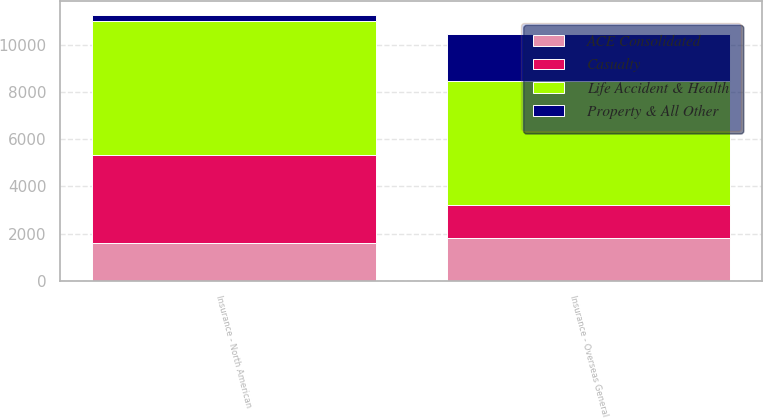Convert chart. <chart><loc_0><loc_0><loc_500><loc_500><stacked_bar_chart><ecel><fcel>Insurance - North American<fcel>Insurance - Overseas General<nl><fcel>ACE Consolidated<fcel>1578<fcel>1800<nl><fcel>Casualty<fcel>3777<fcel>1424<nl><fcel>Property & All Other<fcel>296<fcel>2016<nl><fcel>Life Accident & Health<fcel>5651<fcel>5240<nl></chart> 